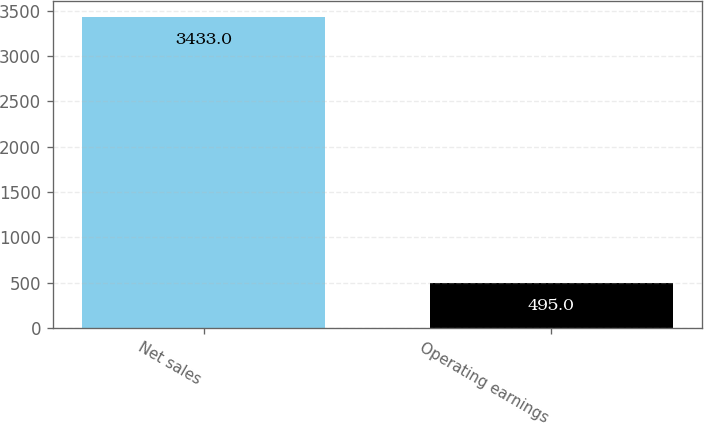Convert chart. <chart><loc_0><loc_0><loc_500><loc_500><bar_chart><fcel>Net sales<fcel>Operating earnings<nl><fcel>3433<fcel>495<nl></chart> 